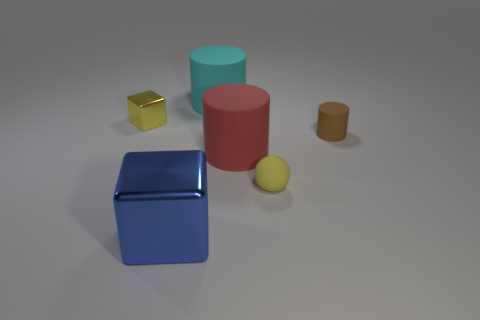Can you describe the different shapes and their colors in this image? Certainly! In the image, there is a large, shiny blue cube and a smaller golden cube with less sheen. There's also a matte red cylinder, a light blue cylinder with a soft sheen, and a small, matte-textured yellow sphere. 